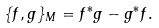<formula> <loc_0><loc_0><loc_500><loc_500>\{ f , g \} _ { M } = f ^ { * } g - g ^ { * } f .</formula> 